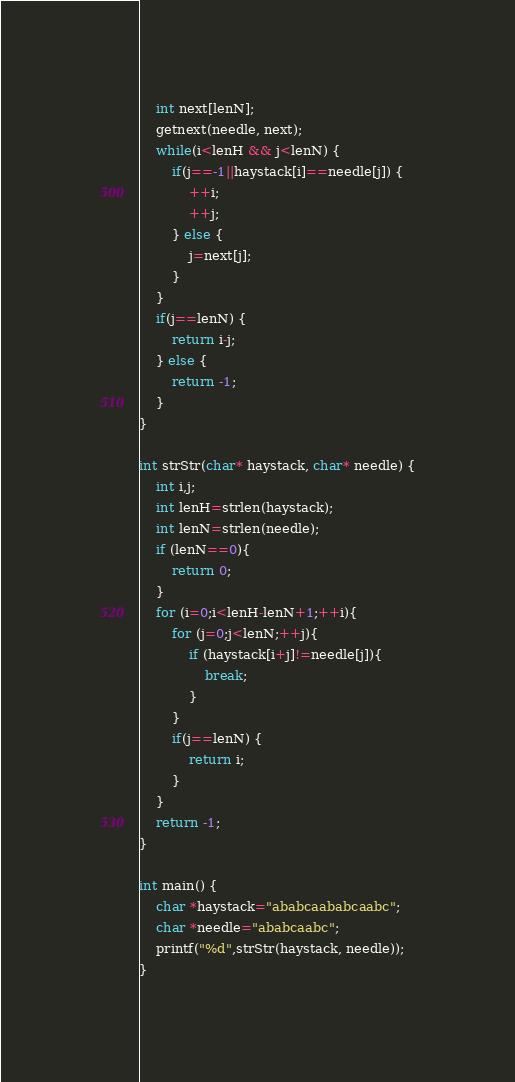<code> <loc_0><loc_0><loc_500><loc_500><_C_>    int next[lenN];
    getnext(needle, next);
    while(i<lenH && j<lenN) {
        if(j==-1||haystack[i]==needle[j]) {
            ++i;
            ++j;
        } else {
            j=next[j];
        }
    }
    if(j==lenN) {
        return i-j;
    } else {
        return -1;
    }
}

int strStr(char* haystack, char* needle) {
    int i,j;
    int lenH=strlen(haystack);
    int lenN=strlen(needle);
    if (lenN==0){
        return 0;
    }
    for (i=0;i<lenH-lenN+1;++i){
        for (j=0;j<lenN;++j){
            if (haystack[i+j]!=needle[j]){
                break;
            }
        }
        if(j==lenN) {
            return i;
        }
    }
    return -1;
}

int main() {
    char *haystack="ababcaababcaabc";
    char *needle="ababcaabc";
    printf("%d",strStr(haystack, needle));
}
</code> 